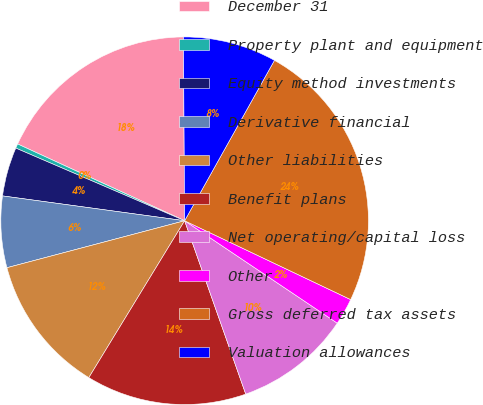Convert chart. <chart><loc_0><loc_0><loc_500><loc_500><pie_chart><fcel>December 31<fcel>Property plant and equipment<fcel>Equity method investments<fcel>Derivative financial<fcel>Other liabilities<fcel>Benefit plans<fcel>Net operating/capital loss<fcel>Other<fcel>Gross deferred tax assets<fcel>Valuation allowances<nl><fcel>18.04%<fcel>0.39%<fcel>4.31%<fcel>6.27%<fcel>12.16%<fcel>14.12%<fcel>10.2%<fcel>2.35%<fcel>23.93%<fcel>8.23%<nl></chart> 